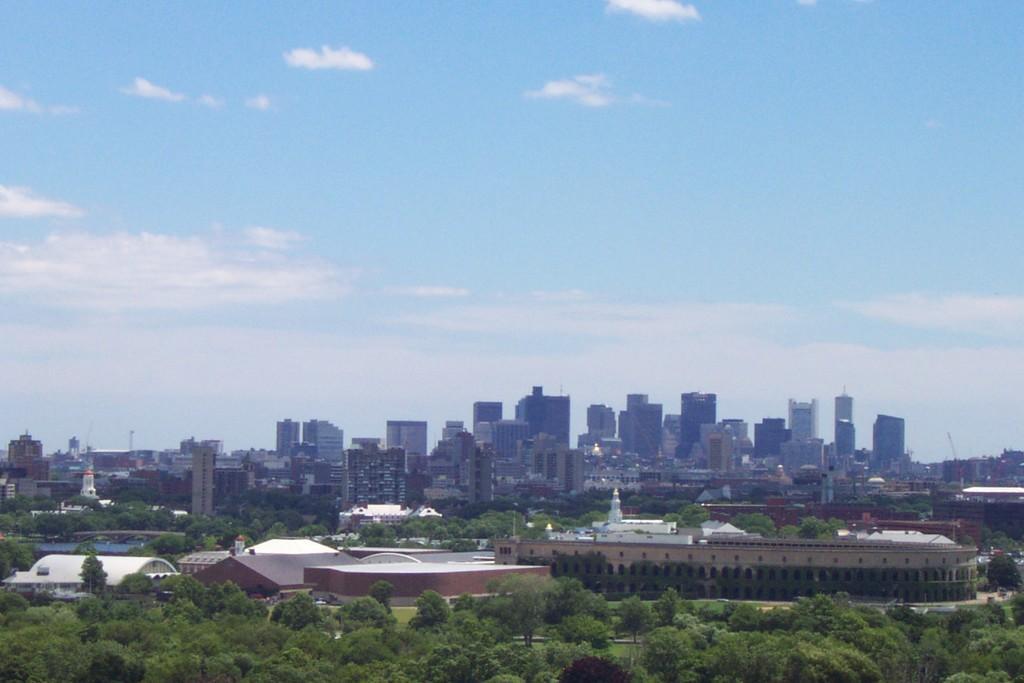Could you give a brief overview of what you see in this image? In this image, I can see the view of a city with the buildings and the trees. In the background, there is the sky. 